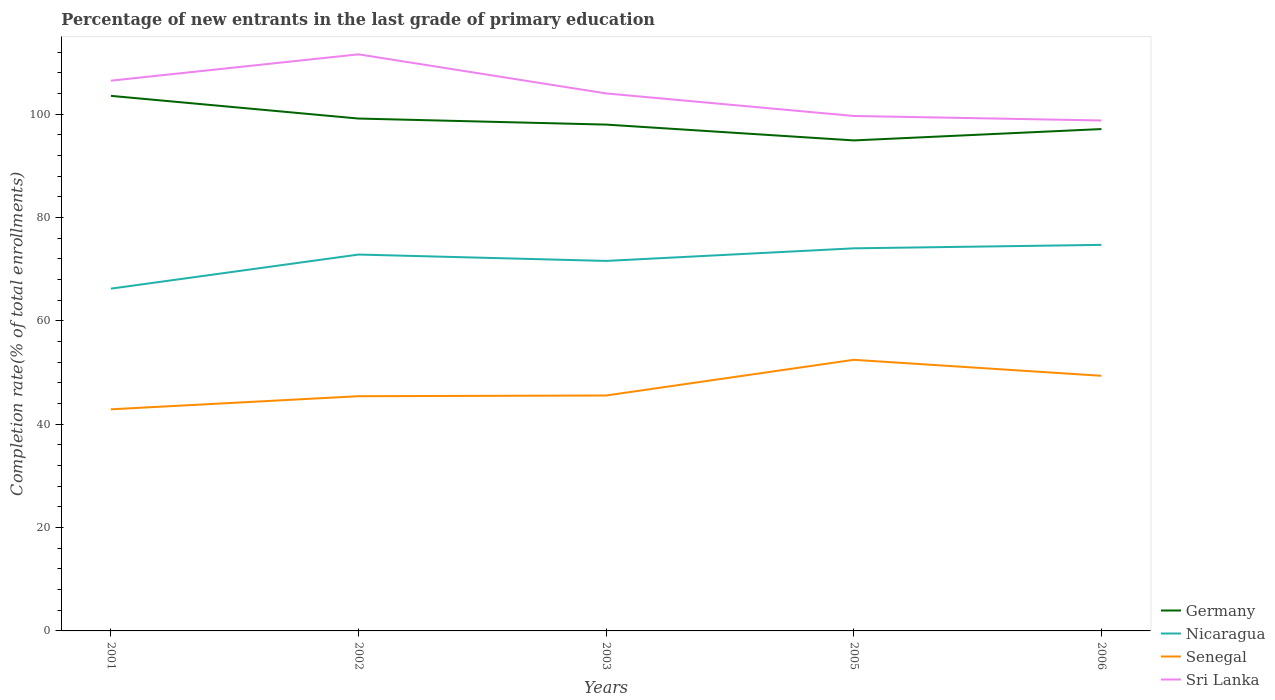Is the number of lines equal to the number of legend labels?
Your answer should be very brief. Yes. Across all years, what is the maximum percentage of new entrants in Sri Lanka?
Your response must be concise. 98.77. In which year was the percentage of new entrants in Nicaragua maximum?
Your answer should be very brief. 2001. What is the total percentage of new entrants in Nicaragua in the graph?
Your answer should be very brief. -1.87. What is the difference between the highest and the second highest percentage of new entrants in Germany?
Your response must be concise. 8.62. What is the difference between the highest and the lowest percentage of new entrants in Sri Lanka?
Offer a terse response. 2. How many lines are there?
Your answer should be compact. 4. What is the difference between two consecutive major ticks on the Y-axis?
Offer a very short reply. 20. Are the values on the major ticks of Y-axis written in scientific E-notation?
Offer a terse response. No. Does the graph contain any zero values?
Offer a very short reply. No. Where does the legend appear in the graph?
Give a very brief answer. Bottom right. How many legend labels are there?
Your answer should be compact. 4. What is the title of the graph?
Make the answer very short. Percentage of new entrants in the last grade of primary education. Does "Greece" appear as one of the legend labels in the graph?
Provide a succinct answer. No. What is the label or title of the Y-axis?
Keep it short and to the point. Completion rate(% of total enrollments). What is the Completion rate(% of total enrollments) of Germany in 2001?
Offer a terse response. 103.53. What is the Completion rate(% of total enrollments) in Nicaragua in 2001?
Offer a terse response. 66.23. What is the Completion rate(% of total enrollments) in Senegal in 2001?
Offer a terse response. 42.88. What is the Completion rate(% of total enrollments) of Sri Lanka in 2001?
Offer a very short reply. 106.47. What is the Completion rate(% of total enrollments) in Germany in 2002?
Keep it short and to the point. 99.14. What is the Completion rate(% of total enrollments) in Nicaragua in 2002?
Give a very brief answer. 72.83. What is the Completion rate(% of total enrollments) in Senegal in 2002?
Offer a terse response. 45.42. What is the Completion rate(% of total enrollments) of Sri Lanka in 2002?
Offer a very short reply. 111.57. What is the Completion rate(% of total enrollments) of Germany in 2003?
Make the answer very short. 97.97. What is the Completion rate(% of total enrollments) of Nicaragua in 2003?
Offer a terse response. 71.59. What is the Completion rate(% of total enrollments) in Senegal in 2003?
Your answer should be compact. 45.55. What is the Completion rate(% of total enrollments) in Sri Lanka in 2003?
Your answer should be very brief. 104. What is the Completion rate(% of total enrollments) of Germany in 2005?
Your answer should be very brief. 94.91. What is the Completion rate(% of total enrollments) in Nicaragua in 2005?
Your answer should be compact. 74.03. What is the Completion rate(% of total enrollments) of Senegal in 2005?
Provide a short and direct response. 52.46. What is the Completion rate(% of total enrollments) of Sri Lanka in 2005?
Ensure brevity in your answer.  99.64. What is the Completion rate(% of total enrollments) of Germany in 2006?
Your answer should be compact. 97.11. What is the Completion rate(% of total enrollments) in Nicaragua in 2006?
Make the answer very short. 74.7. What is the Completion rate(% of total enrollments) in Senegal in 2006?
Make the answer very short. 49.37. What is the Completion rate(% of total enrollments) in Sri Lanka in 2006?
Give a very brief answer. 98.77. Across all years, what is the maximum Completion rate(% of total enrollments) of Germany?
Your answer should be compact. 103.53. Across all years, what is the maximum Completion rate(% of total enrollments) in Nicaragua?
Your response must be concise. 74.7. Across all years, what is the maximum Completion rate(% of total enrollments) of Senegal?
Provide a succinct answer. 52.46. Across all years, what is the maximum Completion rate(% of total enrollments) of Sri Lanka?
Provide a short and direct response. 111.57. Across all years, what is the minimum Completion rate(% of total enrollments) in Germany?
Your answer should be very brief. 94.91. Across all years, what is the minimum Completion rate(% of total enrollments) in Nicaragua?
Give a very brief answer. 66.23. Across all years, what is the minimum Completion rate(% of total enrollments) in Senegal?
Give a very brief answer. 42.88. Across all years, what is the minimum Completion rate(% of total enrollments) of Sri Lanka?
Your answer should be compact. 98.77. What is the total Completion rate(% of total enrollments) in Germany in the graph?
Offer a terse response. 492.66. What is the total Completion rate(% of total enrollments) of Nicaragua in the graph?
Ensure brevity in your answer.  359.37. What is the total Completion rate(% of total enrollments) in Senegal in the graph?
Your response must be concise. 235.68. What is the total Completion rate(% of total enrollments) in Sri Lanka in the graph?
Make the answer very short. 520.45. What is the difference between the Completion rate(% of total enrollments) of Germany in 2001 and that in 2002?
Provide a succinct answer. 4.39. What is the difference between the Completion rate(% of total enrollments) in Nicaragua in 2001 and that in 2002?
Offer a very short reply. -6.6. What is the difference between the Completion rate(% of total enrollments) of Senegal in 2001 and that in 2002?
Offer a terse response. -2.54. What is the difference between the Completion rate(% of total enrollments) in Sri Lanka in 2001 and that in 2002?
Your answer should be compact. -5.1. What is the difference between the Completion rate(% of total enrollments) in Germany in 2001 and that in 2003?
Ensure brevity in your answer.  5.56. What is the difference between the Completion rate(% of total enrollments) of Nicaragua in 2001 and that in 2003?
Provide a short and direct response. -5.36. What is the difference between the Completion rate(% of total enrollments) in Senegal in 2001 and that in 2003?
Ensure brevity in your answer.  -2.67. What is the difference between the Completion rate(% of total enrollments) in Sri Lanka in 2001 and that in 2003?
Keep it short and to the point. 2.47. What is the difference between the Completion rate(% of total enrollments) of Germany in 2001 and that in 2005?
Keep it short and to the point. 8.62. What is the difference between the Completion rate(% of total enrollments) in Nicaragua in 2001 and that in 2005?
Provide a succinct answer. -7.8. What is the difference between the Completion rate(% of total enrollments) of Senegal in 2001 and that in 2005?
Give a very brief answer. -9.58. What is the difference between the Completion rate(% of total enrollments) of Sri Lanka in 2001 and that in 2005?
Your answer should be compact. 6.83. What is the difference between the Completion rate(% of total enrollments) in Germany in 2001 and that in 2006?
Make the answer very short. 6.42. What is the difference between the Completion rate(% of total enrollments) of Nicaragua in 2001 and that in 2006?
Keep it short and to the point. -8.47. What is the difference between the Completion rate(% of total enrollments) in Senegal in 2001 and that in 2006?
Your answer should be very brief. -6.49. What is the difference between the Completion rate(% of total enrollments) of Sri Lanka in 2001 and that in 2006?
Make the answer very short. 7.7. What is the difference between the Completion rate(% of total enrollments) in Germany in 2002 and that in 2003?
Your response must be concise. 1.17. What is the difference between the Completion rate(% of total enrollments) in Nicaragua in 2002 and that in 2003?
Your response must be concise. 1.24. What is the difference between the Completion rate(% of total enrollments) of Senegal in 2002 and that in 2003?
Keep it short and to the point. -0.14. What is the difference between the Completion rate(% of total enrollments) of Sri Lanka in 2002 and that in 2003?
Your answer should be very brief. 7.57. What is the difference between the Completion rate(% of total enrollments) of Germany in 2002 and that in 2005?
Ensure brevity in your answer.  4.23. What is the difference between the Completion rate(% of total enrollments) in Nicaragua in 2002 and that in 2005?
Your answer should be compact. -1.2. What is the difference between the Completion rate(% of total enrollments) in Senegal in 2002 and that in 2005?
Your answer should be very brief. -7.04. What is the difference between the Completion rate(% of total enrollments) of Sri Lanka in 2002 and that in 2005?
Keep it short and to the point. 11.93. What is the difference between the Completion rate(% of total enrollments) in Germany in 2002 and that in 2006?
Your answer should be very brief. 2.03. What is the difference between the Completion rate(% of total enrollments) in Nicaragua in 2002 and that in 2006?
Make the answer very short. -1.87. What is the difference between the Completion rate(% of total enrollments) of Senegal in 2002 and that in 2006?
Ensure brevity in your answer.  -3.95. What is the difference between the Completion rate(% of total enrollments) in Sri Lanka in 2002 and that in 2006?
Provide a succinct answer. 12.8. What is the difference between the Completion rate(% of total enrollments) in Germany in 2003 and that in 2005?
Provide a short and direct response. 3.06. What is the difference between the Completion rate(% of total enrollments) of Nicaragua in 2003 and that in 2005?
Keep it short and to the point. -2.44. What is the difference between the Completion rate(% of total enrollments) of Senegal in 2003 and that in 2005?
Provide a succinct answer. -6.91. What is the difference between the Completion rate(% of total enrollments) in Sri Lanka in 2003 and that in 2005?
Your response must be concise. 4.36. What is the difference between the Completion rate(% of total enrollments) of Germany in 2003 and that in 2006?
Offer a terse response. 0.86. What is the difference between the Completion rate(% of total enrollments) in Nicaragua in 2003 and that in 2006?
Make the answer very short. -3.11. What is the difference between the Completion rate(% of total enrollments) of Senegal in 2003 and that in 2006?
Your answer should be very brief. -3.81. What is the difference between the Completion rate(% of total enrollments) of Sri Lanka in 2003 and that in 2006?
Make the answer very short. 5.23. What is the difference between the Completion rate(% of total enrollments) of Germany in 2005 and that in 2006?
Ensure brevity in your answer.  -2.2. What is the difference between the Completion rate(% of total enrollments) of Nicaragua in 2005 and that in 2006?
Ensure brevity in your answer.  -0.67. What is the difference between the Completion rate(% of total enrollments) of Senegal in 2005 and that in 2006?
Your response must be concise. 3.09. What is the difference between the Completion rate(% of total enrollments) in Sri Lanka in 2005 and that in 2006?
Keep it short and to the point. 0.87. What is the difference between the Completion rate(% of total enrollments) of Germany in 2001 and the Completion rate(% of total enrollments) of Nicaragua in 2002?
Your response must be concise. 30.7. What is the difference between the Completion rate(% of total enrollments) in Germany in 2001 and the Completion rate(% of total enrollments) in Senegal in 2002?
Your answer should be compact. 58.12. What is the difference between the Completion rate(% of total enrollments) in Germany in 2001 and the Completion rate(% of total enrollments) in Sri Lanka in 2002?
Offer a very short reply. -8.04. What is the difference between the Completion rate(% of total enrollments) in Nicaragua in 2001 and the Completion rate(% of total enrollments) in Senegal in 2002?
Your answer should be compact. 20.81. What is the difference between the Completion rate(% of total enrollments) in Nicaragua in 2001 and the Completion rate(% of total enrollments) in Sri Lanka in 2002?
Offer a terse response. -45.34. What is the difference between the Completion rate(% of total enrollments) in Senegal in 2001 and the Completion rate(% of total enrollments) in Sri Lanka in 2002?
Your answer should be compact. -68.69. What is the difference between the Completion rate(% of total enrollments) of Germany in 2001 and the Completion rate(% of total enrollments) of Nicaragua in 2003?
Ensure brevity in your answer.  31.94. What is the difference between the Completion rate(% of total enrollments) in Germany in 2001 and the Completion rate(% of total enrollments) in Senegal in 2003?
Provide a succinct answer. 57.98. What is the difference between the Completion rate(% of total enrollments) of Germany in 2001 and the Completion rate(% of total enrollments) of Sri Lanka in 2003?
Make the answer very short. -0.47. What is the difference between the Completion rate(% of total enrollments) in Nicaragua in 2001 and the Completion rate(% of total enrollments) in Senegal in 2003?
Your response must be concise. 20.67. What is the difference between the Completion rate(% of total enrollments) of Nicaragua in 2001 and the Completion rate(% of total enrollments) of Sri Lanka in 2003?
Keep it short and to the point. -37.77. What is the difference between the Completion rate(% of total enrollments) of Senegal in 2001 and the Completion rate(% of total enrollments) of Sri Lanka in 2003?
Your response must be concise. -61.12. What is the difference between the Completion rate(% of total enrollments) in Germany in 2001 and the Completion rate(% of total enrollments) in Nicaragua in 2005?
Ensure brevity in your answer.  29.5. What is the difference between the Completion rate(% of total enrollments) in Germany in 2001 and the Completion rate(% of total enrollments) in Senegal in 2005?
Provide a short and direct response. 51.07. What is the difference between the Completion rate(% of total enrollments) in Germany in 2001 and the Completion rate(% of total enrollments) in Sri Lanka in 2005?
Your answer should be very brief. 3.89. What is the difference between the Completion rate(% of total enrollments) of Nicaragua in 2001 and the Completion rate(% of total enrollments) of Senegal in 2005?
Make the answer very short. 13.77. What is the difference between the Completion rate(% of total enrollments) of Nicaragua in 2001 and the Completion rate(% of total enrollments) of Sri Lanka in 2005?
Offer a very short reply. -33.41. What is the difference between the Completion rate(% of total enrollments) of Senegal in 2001 and the Completion rate(% of total enrollments) of Sri Lanka in 2005?
Make the answer very short. -56.76. What is the difference between the Completion rate(% of total enrollments) of Germany in 2001 and the Completion rate(% of total enrollments) of Nicaragua in 2006?
Your answer should be compact. 28.83. What is the difference between the Completion rate(% of total enrollments) of Germany in 2001 and the Completion rate(% of total enrollments) of Senegal in 2006?
Make the answer very short. 54.17. What is the difference between the Completion rate(% of total enrollments) in Germany in 2001 and the Completion rate(% of total enrollments) in Sri Lanka in 2006?
Keep it short and to the point. 4.76. What is the difference between the Completion rate(% of total enrollments) of Nicaragua in 2001 and the Completion rate(% of total enrollments) of Senegal in 2006?
Your answer should be very brief. 16.86. What is the difference between the Completion rate(% of total enrollments) of Nicaragua in 2001 and the Completion rate(% of total enrollments) of Sri Lanka in 2006?
Your answer should be very brief. -32.54. What is the difference between the Completion rate(% of total enrollments) of Senegal in 2001 and the Completion rate(% of total enrollments) of Sri Lanka in 2006?
Provide a short and direct response. -55.89. What is the difference between the Completion rate(% of total enrollments) in Germany in 2002 and the Completion rate(% of total enrollments) in Nicaragua in 2003?
Provide a short and direct response. 27.55. What is the difference between the Completion rate(% of total enrollments) in Germany in 2002 and the Completion rate(% of total enrollments) in Senegal in 2003?
Your response must be concise. 53.59. What is the difference between the Completion rate(% of total enrollments) of Germany in 2002 and the Completion rate(% of total enrollments) of Sri Lanka in 2003?
Make the answer very short. -4.86. What is the difference between the Completion rate(% of total enrollments) in Nicaragua in 2002 and the Completion rate(% of total enrollments) in Senegal in 2003?
Make the answer very short. 27.27. What is the difference between the Completion rate(% of total enrollments) in Nicaragua in 2002 and the Completion rate(% of total enrollments) in Sri Lanka in 2003?
Give a very brief answer. -31.18. What is the difference between the Completion rate(% of total enrollments) in Senegal in 2002 and the Completion rate(% of total enrollments) in Sri Lanka in 2003?
Provide a short and direct response. -58.59. What is the difference between the Completion rate(% of total enrollments) in Germany in 2002 and the Completion rate(% of total enrollments) in Nicaragua in 2005?
Your answer should be compact. 25.11. What is the difference between the Completion rate(% of total enrollments) in Germany in 2002 and the Completion rate(% of total enrollments) in Senegal in 2005?
Make the answer very short. 46.68. What is the difference between the Completion rate(% of total enrollments) in Germany in 2002 and the Completion rate(% of total enrollments) in Sri Lanka in 2005?
Make the answer very short. -0.5. What is the difference between the Completion rate(% of total enrollments) in Nicaragua in 2002 and the Completion rate(% of total enrollments) in Senegal in 2005?
Make the answer very short. 20.37. What is the difference between the Completion rate(% of total enrollments) of Nicaragua in 2002 and the Completion rate(% of total enrollments) of Sri Lanka in 2005?
Offer a terse response. -26.81. What is the difference between the Completion rate(% of total enrollments) of Senegal in 2002 and the Completion rate(% of total enrollments) of Sri Lanka in 2005?
Provide a short and direct response. -54.22. What is the difference between the Completion rate(% of total enrollments) in Germany in 2002 and the Completion rate(% of total enrollments) in Nicaragua in 2006?
Your answer should be compact. 24.44. What is the difference between the Completion rate(% of total enrollments) in Germany in 2002 and the Completion rate(% of total enrollments) in Senegal in 2006?
Keep it short and to the point. 49.77. What is the difference between the Completion rate(% of total enrollments) in Germany in 2002 and the Completion rate(% of total enrollments) in Sri Lanka in 2006?
Ensure brevity in your answer.  0.37. What is the difference between the Completion rate(% of total enrollments) in Nicaragua in 2002 and the Completion rate(% of total enrollments) in Senegal in 2006?
Ensure brevity in your answer.  23.46. What is the difference between the Completion rate(% of total enrollments) of Nicaragua in 2002 and the Completion rate(% of total enrollments) of Sri Lanka in 2006?
Your response must be concise. -25.94. What is the difference between the Completion rate(% of total enrollments) of Senegal in 2002 and the Completion rate(% of total enrollments) of Sri Lanka in 2006?
Your response must be concise. -53.35. What is the difference between the Completion rate(% of total enrollments) of Germany in 2003 and the Completion rate(% of total enrollments) of Nicaragua in 2005?
Give a very brief answer. 23.94. What is the difference between the Completion rate(% of total enrollments) of Germany in 2003 and the Completion rate(% of total enrollments) of Senegal in 2005?
Offer a terse response. 45.51. What is the difference between the Completion rate(% of total enrollments) of Germany in 2003 and the Completion rate(% of total enrollments) of Sri Lanka in 2005?
Your answer should be compact. -1.67. What is the difference between the Completion rate(% of total enrollments) of Nicaragua in 2003 and the Completion rate(% of total enrollments) of Senegal in 2005?
Provide a short and direct response. 19.13. What is the difference between the Completion rate(% of total enrollments) of Nicaragua in 2003 and the Completion rate(% of total enrollments) of Sri Lanka in 2005?
Ensure brevity in your answer.  -28.05. What is the difference between the Completion rate(% of total enrollments) in Senegal in 2003 and the Completion rate(% of total enrollments) in Sri Lanka in 2005?
Provide a short and direct response. -54.09. What is the difference between the Completion rate(% of total enrollments) of Germany in 2003 and the Completion rate(% of total enrollments) of Nicaragua in 2006?
Your answer should be compact. 23.27. What is the difference between the Completion rate(% of total enrollments) in Germany in 2003 and the Completion rate(% of total enrollments) in Senegal in 2006?
Your response must be concise. 48.61. What is the difference between the Completion rate(% of total enrollments) of Germany in 2003 and the Completion rate(% of total enrollments) of Sri Lanka in 2006?
Make the answer very short. -0.8. What is the difference between the Completion rate(% of total enrollments) of Nicaragua in 2003 and the Completion rate(% of total enrollments) of Senegal in 2006?
Ensure brevity in your answer.  22.23. What is the difference between the Completion rate(% of total enrollments) of Nicaragua in 2003 and the Completion rate(% of total enrollments) of Sri Lanka in 2006?
Make the answer very short. -27.18. What is the difference between the Completion rate(% of total enrollments) in Senegal in 2003 and the Completion rate(% of total enrollments) in Sri Lanka in 2006?
Give a very brief answer. -53.22. What is the difference between the Completion rate(% of total enrollments) in Germany in 2005 and the Completion rate(% of total enrollments) in Nicaragua in 2006?
Ensure brevity in your answer.  20.21. What is the difference between the Completion rate(% of total enrollments) of Germany in 2005 and the Completion rate(% of total enrollments) of Senegal in 2006?
Provide a succinct answer. 45.54. What is the difference between the Completion rate(% of total enrollments) of Germany in 2005 and the Completion rate(% of total enrollments) of Sri Lanka in 2006?
Your answer should be compact. -3.86. What is the difference between the Completion rate(% of total enrollments) in Nicaragua in 2005 and the Completion rate(% of total enrollments) in Senegal in 2006?
Give a very brief answer. 24.66. What is the difference between the Completion rate(% of total enrollments) in Nicaragua in 2005 and the Completion rate(% of total enrollments) in Sri Lanka in 2006?
Offer a very short reply. -24.74. What is the difference between the Completion rate(% of total enrollments) in Senegal in 2005 and the Completion rate(% of total enrollments) in Sri Lanka in 2006?
Your response must be concise. -46.31. What is the average Completion rate(% of total enrollments) of Germany per year?
Make the answer very short. 98.53. What is the average Completion rate(% of total enrollments) in Nicaragua per year?
Give a very brief answer. 71.87. What is the average Completion rate(% of total enrollments) in Senegal per year?
Make the answer very short. 47.14. What is the average Completion rate(% of total enrollments) in Sri Lanka per year?
Make the answer very short. 104.09. In the year 2001, what is the difference between the Completion rate(% of total enrollments) in Germany and Completion rate(% of total enrollments) in Nicaragua?
Keep it short and to the point. 37.3. In the year 2001, what is the difference between the Completion rate(% of total enrollments) of Germany and Completion rate(% of total enrollments) of Senegal?
Give a very brief answer. 60.65. In the year 2001, what is the difference between the Completion rate(% of total enrollments) in Germany and Completion rate(% of total enrollments) in Sri Lanka?
Your answer should be very brief. -2.94. In the year 2001, what is the difference between the Completion rate(% of total enrollments) of Nicaragua and Completion rate(% of total enrollments) of Senegal?
Make the answer very short. 23.35. In the year 2001, what is the difference between the Completion rate(% of total enrollments) in Nicaragua and Completion rate(% of total enrollments) in Sri Lanka?
Provide a short and direct response. -40.24. In the year 2001, what is the difference between the Completion rate(% of total enrollments) of Senegal and Completion rate(% of total enrollments) of Sri Lanka?
Provide a short and direct response. -63.59. In the year 2002, what is the difference between the Completion rate(% of total enrollments) of Germany and Completion rate(% of total enrollments) of Nicaragua?
Your answer should be very brief. 26.31. In the year 2002, what is the difference between the Completion rate(% of total enrollments) in Germany and Completion rate(% of total enrollments) in Senegal?
Ensure brevity in your answer.  53.72. In the year 2002, what is the difference between the Completion rate(% of total enrollments) of Germany and Completion rate(% of total enrollments) of Sri Lanka?
Ensure brevity in your answer.  -12.43. In the year 2002, what is the difference between the Completion rate(% of total enrollments) in Nicaragua and Completion rate(% of total enrollments) in Senegal?
Provide a succinct answer. 27.41. In the year 2002, what is the difference between the Completion rate(% of total enrollments) in Nicaragua and Completion rate(% of total enrollments) in Sri Lanka?
Offer a terse response. -38.74. In the year 2002, what is the difference between the Completion rate(% of total enrollments) of Senegal and Completion rate(% of total enrollments) of Sri Lanka?
Ensure brevity in your answer.  -66.15. In the year 2003, what is the difference between the Completion rate(% of total enrollments) of Germany and Completion rate(% of total enrollments) of Nicaragua?
Provide a short and direct response. 26.38. In the year 2003, what is the difference between the Completion rate(% of total enrollments) in Germany and Completion rate(% of total enrollments) in Senegal?
Ensure brevity in your answer.  52.42. In the year 2003, what is the difference between the Completion rate(% of total enrollments) in Germany and Completion rate(% of total enrollments) in Sri Lanka?
Provide a short and direct response. -6.03. In the year 2003, what is the difference between the Completion rate(% of total enrollments) in Nicaragua and Completion rate(% of total enrollments) in Senegal?
Ensure brevity in your answer.  26.04. In the year 2003, what is the difference between the Completion rate(% of total enrollments) in Nicaragua and Completion rate(% of total enrollments) in Sri Lanka?
Your response must be concise. -32.41. In the year 2003, what is the difference between the Completion rate(% of total enrollments) of Senegal and Completion rate(% of total enrollments) of Sri Lanka?
Offer a terse response. -58.45. In the year 2005, what is the difference between the Completion rate(% of total enrollments) in Germany and Completion rate(% of total enrollments) in Nicaragua?
Give a very brief answer. 20.88. In the year 2005, what is the difference between the Completion rate(% of total enrollments) in Germany and Completion rate(% of total enrollments) in Senegal?
Ensure brevity in your answer.  42.45. In the year 2005, what is the difference between the Completion rate(% of total enrollments) in Germany and Completion rate(% of total enrollments) in Sri Lanka?
Your answer should be very brief. -4.73. In the year 2005, what is the difference between the Completion rate(% of total enrollments) of Nicaragua and Completion rate(% of total enrollments) of Senegal?
Give a very brief answer. 21.57. In the year 2005, what is the difference between the Completion rate(% of total enrollments) of Nicaragua and Completion rate(% of total enrollments) of Sri Lanka?
Your answer should be compact. -25.61. In the year 2005, what is the difference between the Completion rate(% of total enrollments) of Senegal and Completion rate(% of total enrollments) of Sri Lanka?
Give a very brief answer. -47.18. In the year 2006, what is the difference between the Completion rate(% of total enrollments) of Germany and Completion rate(% of total enrollments) of Nicaragua?
Make the answer very short. 22.41. In the year 2006, what is the difference between the Completion rate(% of total enrollments) of Germany and Completion rate(% of total enrollments) of Senegal?
Ensure brevity in your answer.  47.74. In the year 2006, what is the difference between the Completion rate(% of total enrollments) of Germany and Completion rate(% of total enrollments) of Sri Lanka?
Offer a terse response. -1.66. In the year 2006, what is the difference between the Completion rate(% of total enrollments) of Nicaragua and Completion rate(% of total enrollments) of Senegal?
Provide a succinct answer. 25.33. In the year 2006, what is the difference between the Completion rate(% of total enrollments) of Nicaragua and Completion rate(% of total enrollments) of Sri Lanka?
Give a very brief answer. -24.07. In the year 2006, what is the difference between the Completion rate(% of total enrollments) of Senegal and Completion rate(% of total enrollments) of Sri Lanka?
Ensure brevity in your answer.  -49.4. What is the ratio of the Completion rate(% of total enrollments) in Germany in 2001 to that in 2002?
Ensure brevity in your answer.  1.04. What is the ratio of the Completion rate(% of total enrollments) in Nicaragua in 2001 to that in 2002?
Provide a succinct answer. 0.91. What is the ratio of the Completion rate(% of total enrollments) of Senegal in 2001 to that in 2002?
Your answer should be very brief. 0.94. What is the ratio of the Completion rate(% of total enrollments) of Sri Lanka in 2001 to that in 2002?
Your answer should be compact. 0.95. What is the ratio of the Completion rate(% of total enrollments) in Germany in 2001 to that in 2003?
Offer a very short reply. 1.06. What is the ratio of the Completion rate(% of total enrollments) in Nicaragua in 2001 to that in 2003?
Offer a very short reply. 0.93. What is the ratio of the Completion rate(% of total enrollments) in Senegal in 2001 to that in 2003?
Give a very brief answer. 0.94. What is the ratio of the Completion rate(% of total enrollments) of Sri Lanka in 2001 to that in 2003?
Your answer should be very brief. 1.02. What is the ratio of the Completion rate(% of total enrollments) of Germany in 2001 to that in 2005?
Give a very brief answer. 1.09. What is the ratio of the Completion rate(% of total enrollments) of Nicaragua in 2001 to that in 2005?
Your answer should be very brief. 0.89. What is the ratio of the Completion rate(% of total enrollments) of Senegal in 2001 to that in 2005?
Your response must be concise. 0.82. What is the ratio of the Completion rate(% of total enrollments) of Sri Lanka in 2001 to that in 2005?
Offer a very short reply. 1.07. What is the ratio of the Completion rate(% of total enrollments) in Germany in 2001 to that in 2006?
Give a very brief answer. 1.07. What is the ratio of the Completion rate(% of total enrollments) in Nicaragua in 2001 to that in 2006?
Offer a terse response. 0.89. What is the ratio of the Completion rate(% of total enrollments) of Senegal in 2001 to that in 2006?
Your answer should be compact. 0.87. What is the ratio of the Completion rate(% of total enrollments) of Sri Lanka in 2001 to that in 2006?
Offer a very short reply. 1.08. What is the ratio of the Completion rate(% of total enrollments) in Germany in 2002 to that in 2003?
Provide a short and direct response. 1.01. What is the ratio of the Completion rate(% of total enrollments) of Nicaragua in 2002 to that in 2003?
Keep it short and to the point. 1.02. What is the ratio of the Completion rate(% of total enrollments) of Sri Lanka in 2002 to that in 2003?
Keep it short and to the point. 1.07. What is the ratio of the Completion rate(% of total enrollments) of Germany in 2002 to that in 2005?
Keep it short and to the point. 1.04. What is the ratio of the Completion rate(% of total enrollments) in Nicaragua in 2002 to that in 2005?
Your answer should be very brief. 0.98. What is the ratio of the Completion rate(% of total enrollments) of Senegal in 2002 to that in 2005?
Offer a very short reply. 0.87. What is the ratio of the Completion rate(% of total enrollments) of Sri Lanka in 2002 to that in 2005?
Your response must be concise. 1.12. What is the ratio of the Completion rate(% of total enrollments) of Germany in 2002 to that in 2006?
Your answer should be very brief. 1.02. What is the ratio of the Completion rate(% of total enrollments) of Nicaragua in 2002 to that in 2006?
Offer a very short reply. 0.97. What is the ratio of the Completion rate(% of total enrollments) in Sri Lanka in 2002 to that in 2006?
Offer a terse response. 1.13. What is the ratio of the Completion rate(% of total enrollments) in Germany in 2003 to that in 2005?
Make the answer very short. 1.03. What is the ratio of the Completion rate(% of total enrollments) of Nicaragua in 2003 to that in 2005?
Make the answer very short. 0.97. What is the ratio of the Completion rate(% of total enrollments) of Senegal in 2003 to that in 2005?
Your answer should be very brief. 0.87. What is the ratio of the Completion rate(% of total enrollments) of Sri Lanka in 2003 to that in 2005?
Give a very brief answer. 1.04. What is the ratio of the Completion rate(% of total enrollments) of Germany in 2003 to that in 2006?
Offer a terse response. 1.01. What is the ratio of the Completion rate(% of total enrollments) in Nicaragua in 2003 to that in 2006?
Provide a short and direct response. 0.96. What is the ratio of the Completion rate(% of total enrollments) of Senegal in 2003 to that in 2006?
Keep it short and to the point. 0.92. What is the ratio of the Completion rate(% of total enrollments) in Sri Lanka in 2003 to that in 2006?
Offer a terse response. 1.05. What is the ratio of the Completion rate(% of total enrollments) of Germany in 2005 to that in 2006?
Your answer should be very brief. 0.98. What is the ratio of the Completion rate(% of total enrollments) in Senegal in 2005 to that in 2006?
Give a very brief answer. 1.06. What is the ratio of the Completion rate(% of total enrollments) in Sri Lanka in 2005 to that in 2006?
Keep it short and to the point. 1.01. What is the difference between the highest and the second highest Completion rate(% of total enrollments) of Germany?
Offer a very short reply. 4.39. What is the difference between the highest and the second highest Completion rate(% of total enrollments) in Nicaragua?
Your answer should be compact. 0.67. What is the difference between the highest and the second highest Completion rate(% of total enrollments) in Senegal?
Provide a succinct answer. 3.09. What is the difference between the highest and the second highest Completion rate(% of total enrollments) of Sri Lanka?
Ensure brevity in your answer.  5.1. What is the difference between the highest and the lowest Completion rate(% of total enrollments) in Germany?
Your answer should be compact. 8.62. What is the difference between the highest and the lowest Completion rate(% of total enrollments) in Nicaragua?
Your answer should be compact. 8.47. What is the difference between the highest and the lowest Completion rate(% of total enrollments) of Senegal?
Offer a terse response. 9.58. What is the difference between the highest and the lowest Completion rate(% of total enrollments) of Sri Lanka?
Your answer should be very brief. 12.8. 